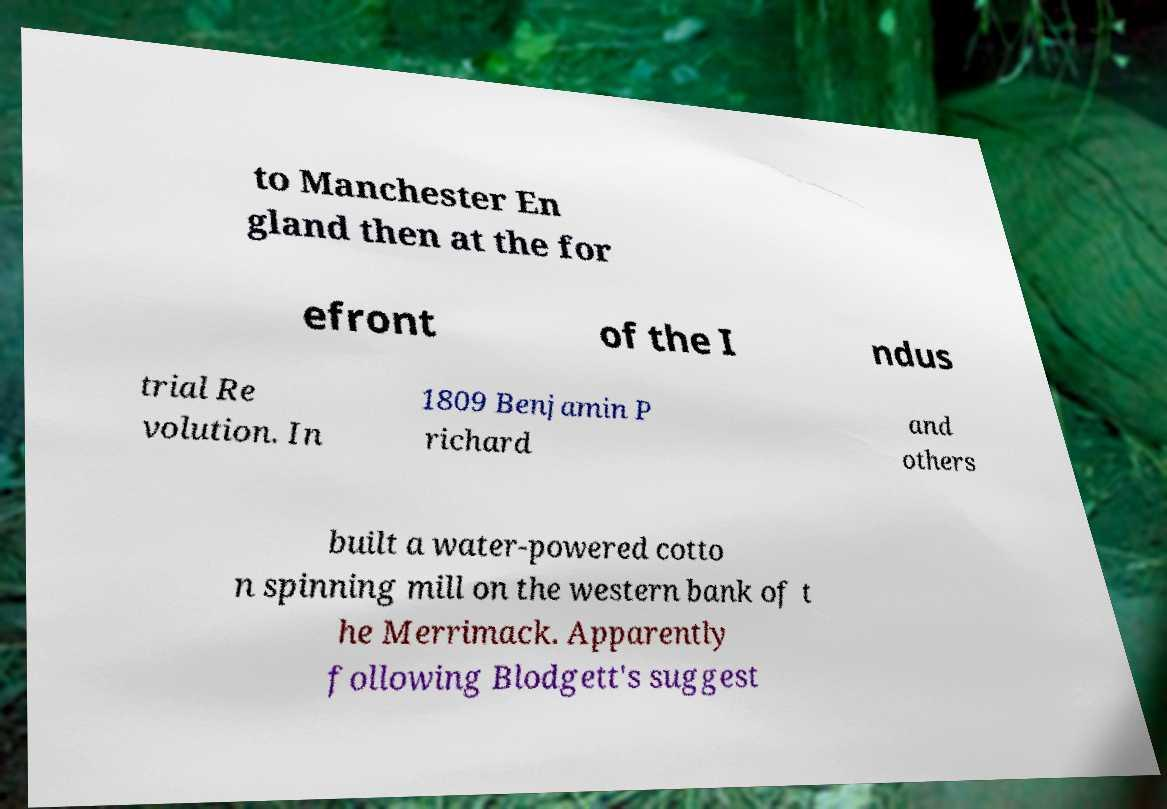There's text embedded in this image that I need extracted. Can you transcribe it verbatim? to Manchester En gland then at the for efront of the I ndus trial Re volution. In 1809 Benjamin P richard and others built a water-powered cotto n spinning mill on the western bank of t he Merrimack. Apparently following Blodgett's suggest 